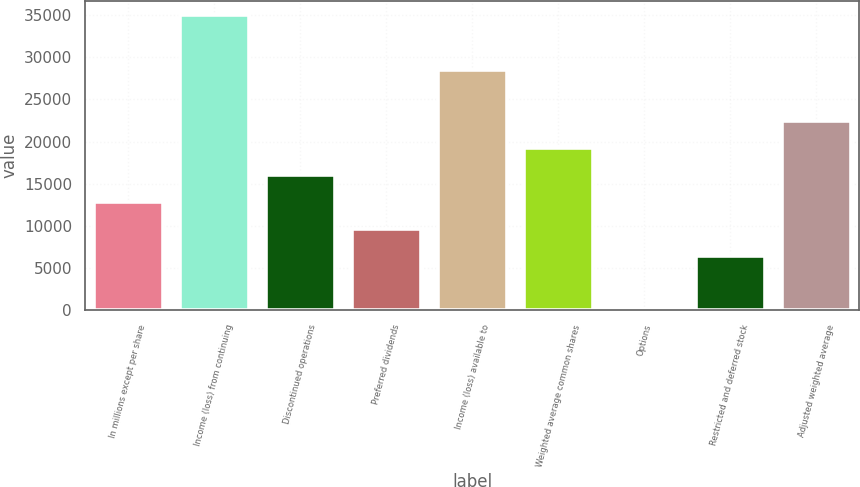Convert chart. <chart><loc_0><loc_0><loc_500><loc_500><bar_chart><fcel>In millions except per share<fcel>Income (loss) from continuing<fcel>Discontinued operations<fcel>Preferred dividends<fcel>Income (loss) available to<fcel>Weighted average common shares<fcel>Options<fcel>Restricted and deferred stock<fcel>Adjusted weighted average<nl><fcel>12837.8<fcel>34957.7<fcel>16047.1<fcel>9628.41<fcel>28539<fcel>19256.5<fcel>0.3<fcel>6419.04<fcel>22465.9<nl></chart> 